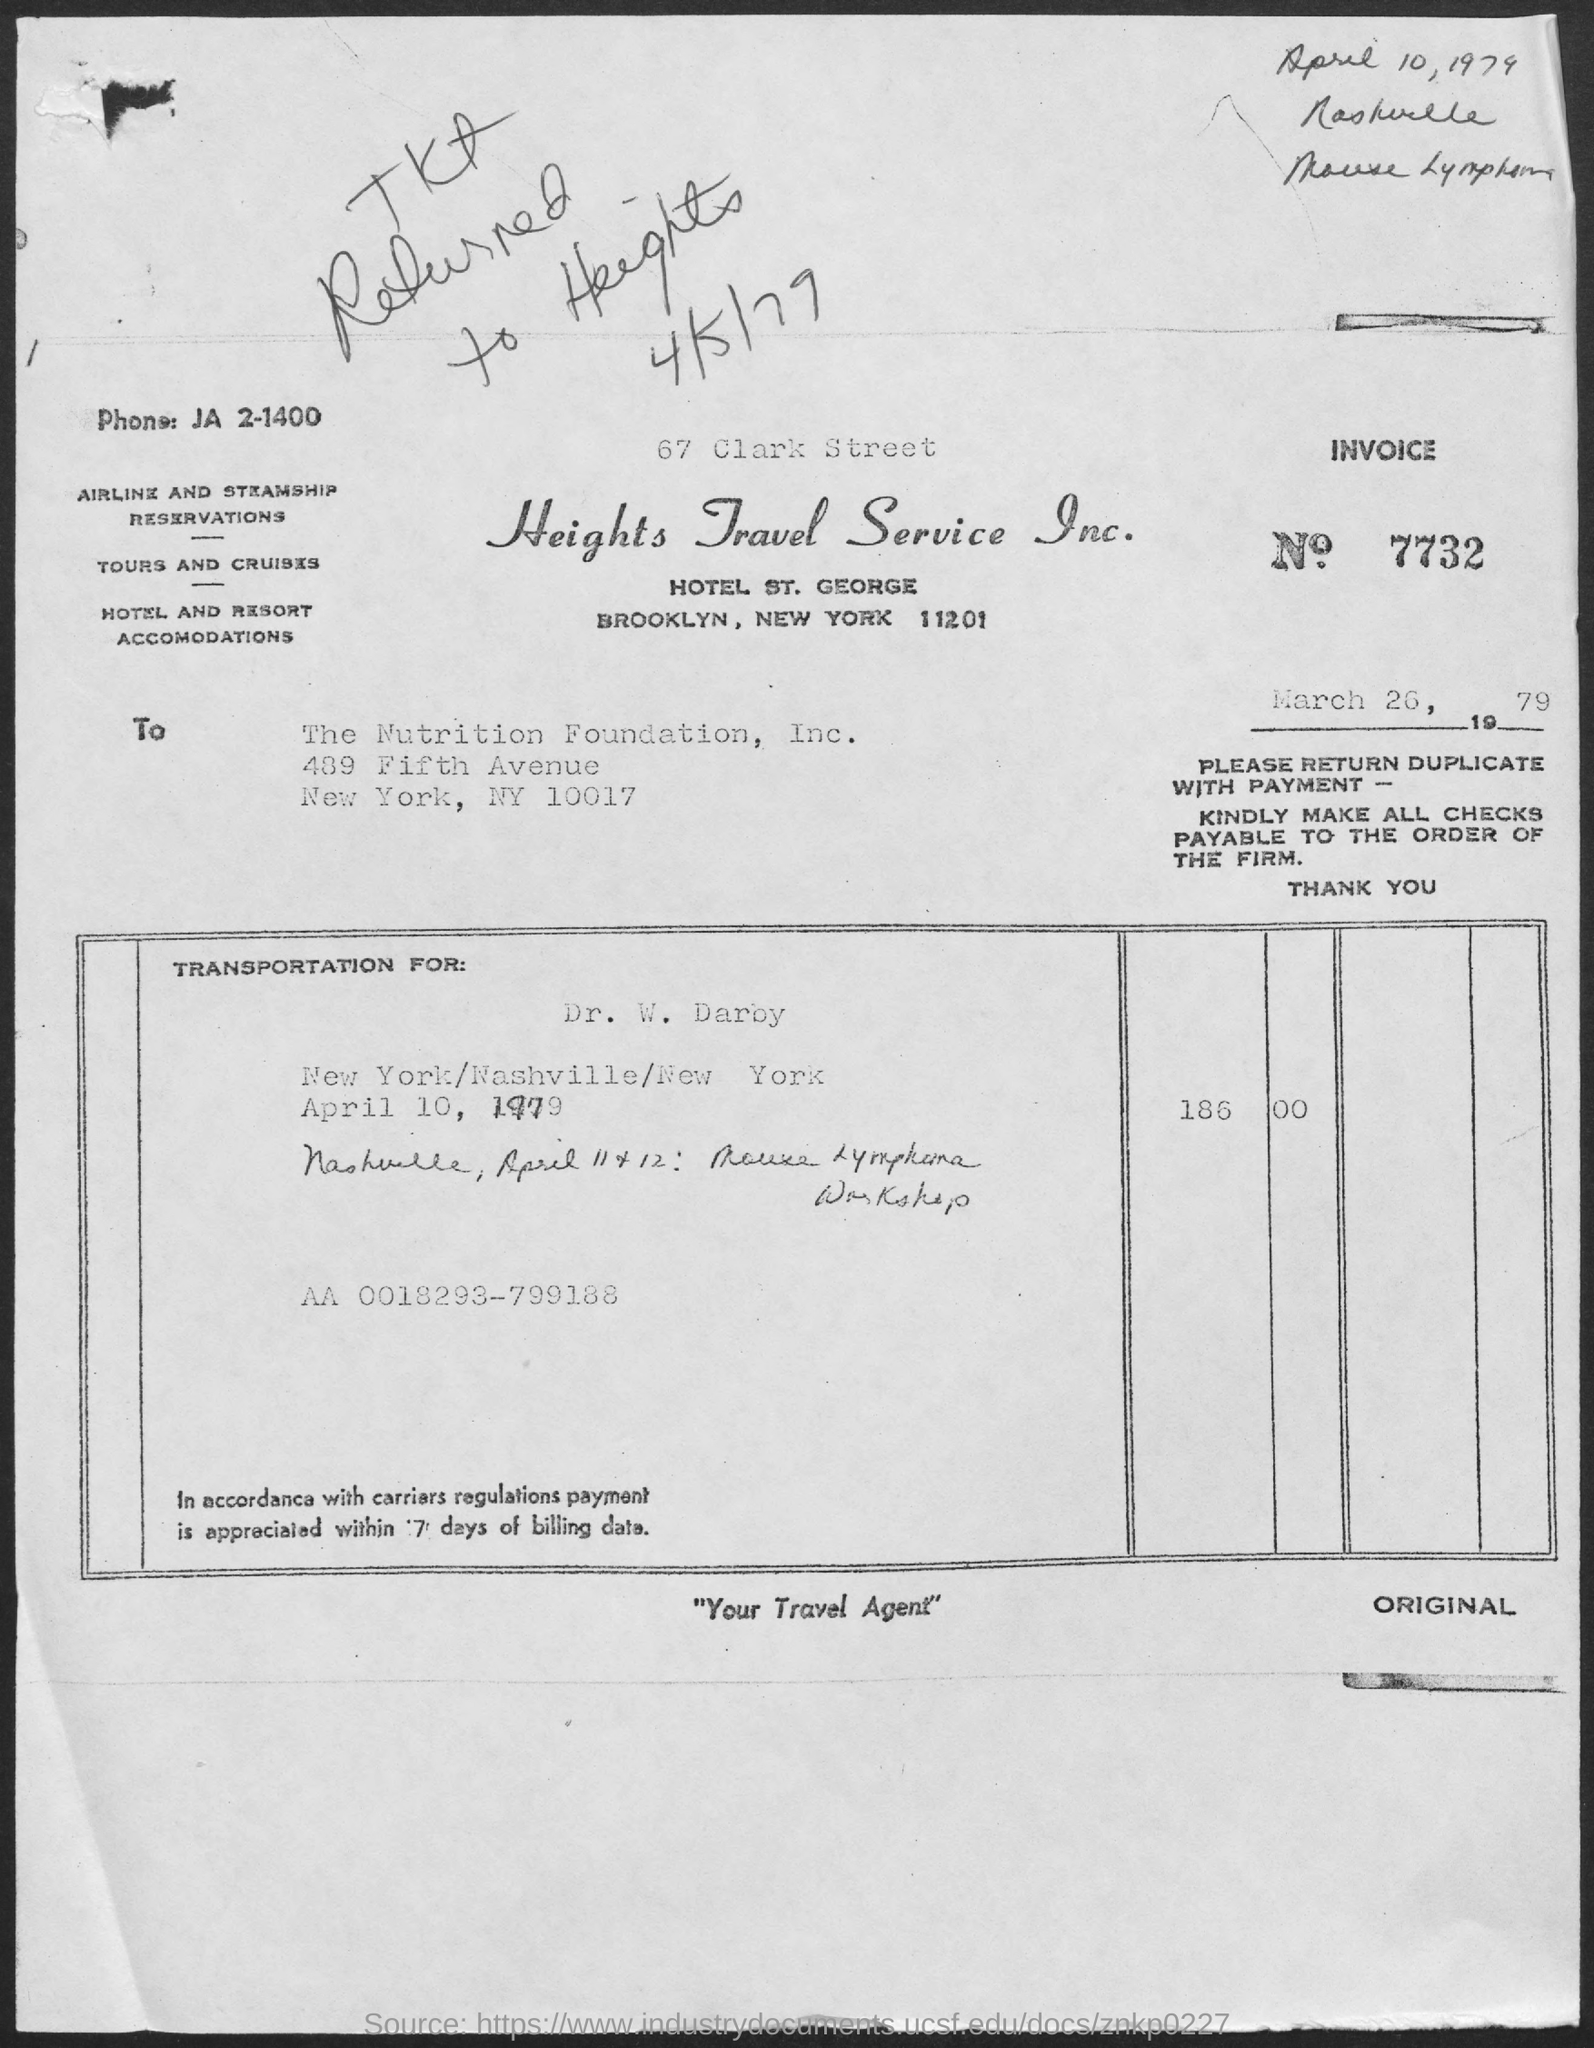What is the name of the travel service?
Give a very brief answer. Heights Travel Service Inc. What is the invoice no
Provide a succinct answer. 7732. 